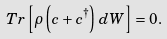<formula> <loc_0><loc_0><loc_500><loc_500>T r \left [ \rho \left ( c + c ^ { \dagger } \right ) \, d W \right ] = 0 .</formula> 